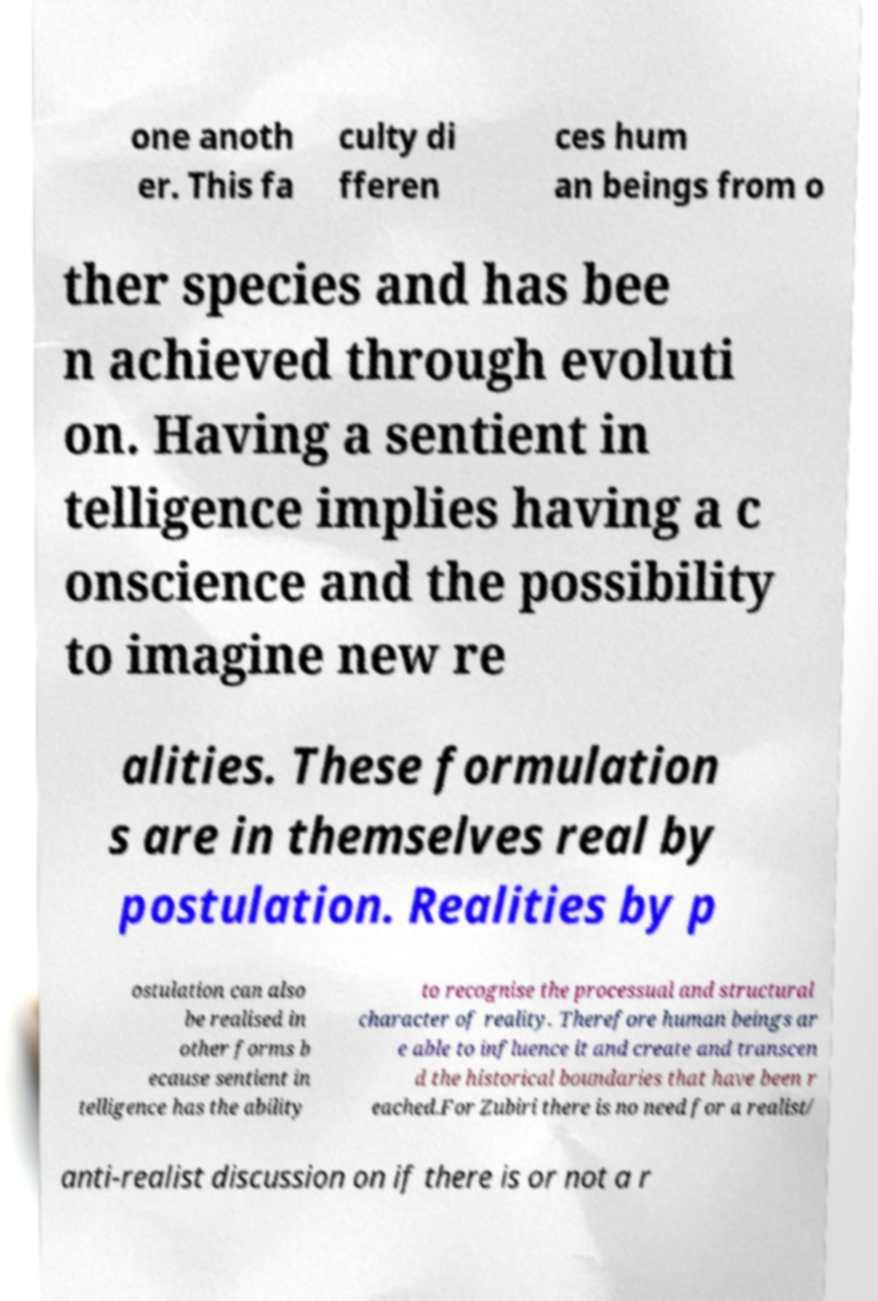Can you read and provide the text displayed in the image?This photo seems to have some interesting text. Can you extract and type it out for me? one anoth er. This fa culty di fferen ces hum an beings from o ther species and has bee n achieved through evoluti on. Having a sentient in telligence implies having a c onscience and the possibility to imagine new re alities. These formulation s are in themselves real by postulation. Realities by p ostulation can also be realised in other forms b ecause sentient in telligence has the ability to recognise the processual and structural character of reality. Therefore human beings ar e able to influence it and create and transcen d the historical boundaries that have been r eached.For Zubiri there is no need for a realist/ anti-realist discussion on if there is or not a r 